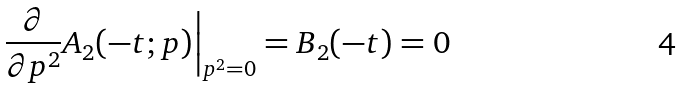<formula> <loc_0><loc_0><loc_500><loc_500>\frac { \partial } { \partial p ^ { 2 } } A _ { 2 } ( - t ; p ) \Big | _ { p ^ { 2 } = 0 } = B _ { 2 } ( - t ) = 0</formula> 